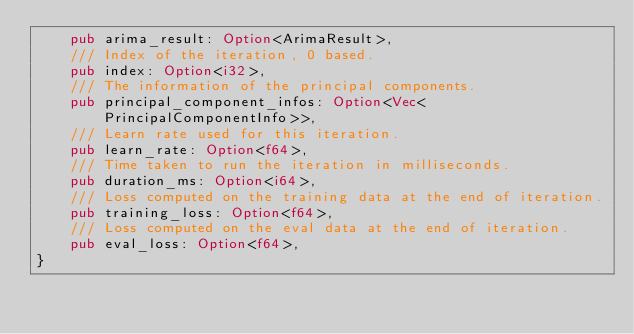<code> <loc_0><loc_0><loc_500><loc_500><_Rust_>    pub arima_result: Option<ArimaResult>,
    /// Index of the iteration, 0 based.
    pub index: Option<i32>,
    /// The information of the principal components.
    pub principal_component_infos: Option<Vec<PrincipalComponentInfo>>,
    /// Learn rate used for this iteration.
    pub learn_rate: Option<f64>,
    /// Time taken to run the iteration in milliseconds.
    pub duration_ms: Option<i64>,
    /// Loss computed on the training data at the end of iteration.
    pub training_loss: Option<f64>,
    /// Loss computed on the eval data at the end of iteration.
    pub eval_loss: Option<f64>,
}
</code> 